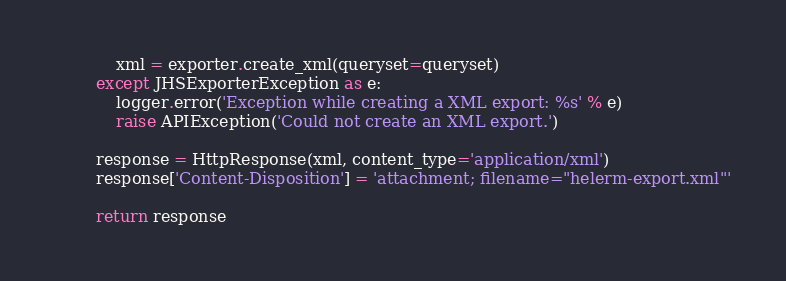Convert code to text. <code><loc_0><loc_0><loc_500><loc_500><_Python_>            xml = exporter.create_xml(queryset=queryset)
        except JHSExporterException as e:
            logger.error('Exception while creating a XML export: %s' % e)
            raise APIException('Could not create an XML export.')

        response = HttpResponse(xml, content_type='application/xml')
        response['Content-Disposition'] = 'attachment; filename="helerm-export.xml"'

        return response
</code> 